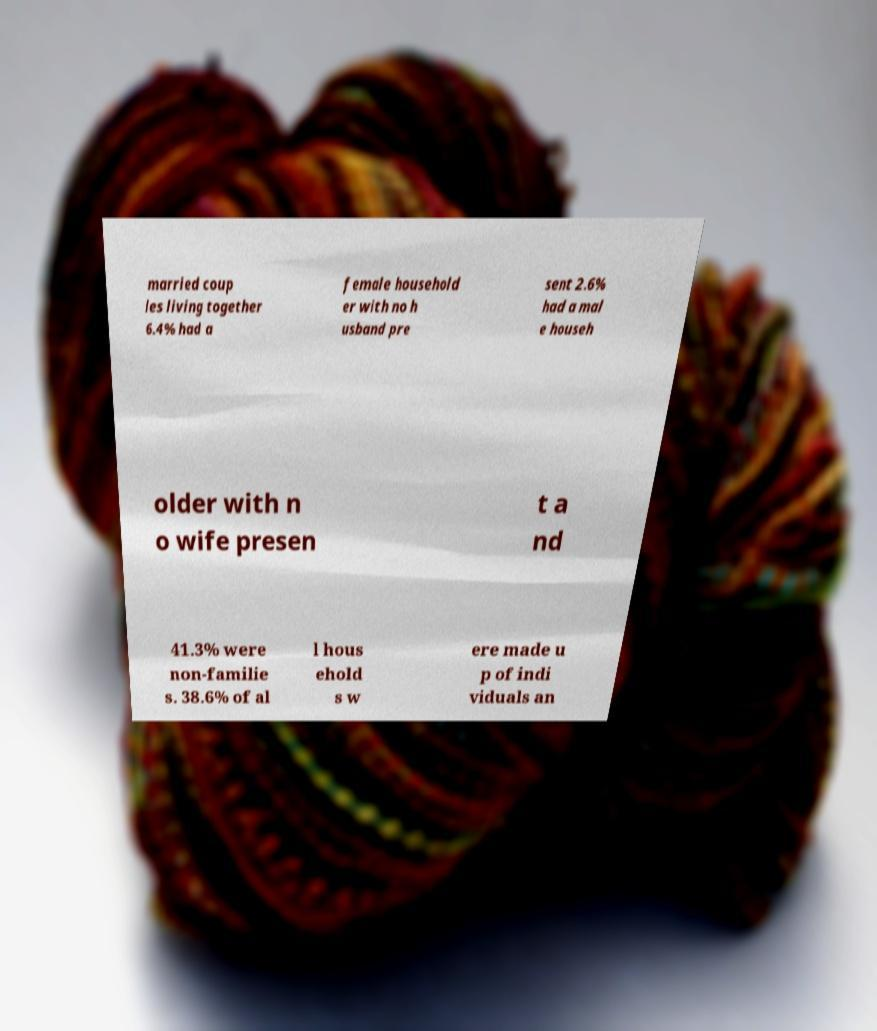Can you read and provide the text displayed in the image?This photo seems to have some interesting text. Can you extract and type it out for me? married coup les living together 6.4% had a female household er with no h usband pre sent 2.6% had a mal e househ older with n o wife presen t a nd 41.3% were non-familie s. 38.6% of al l hous ehold s w ere made u p of indi viduals an 